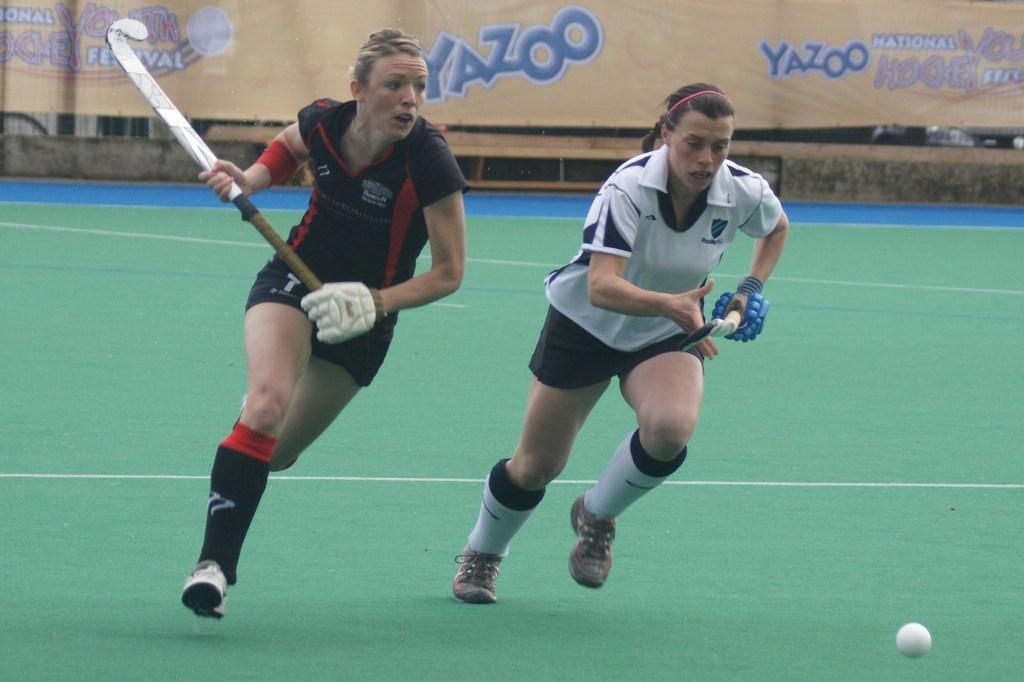Can you describe this image briefly? In this image there are persons playing hockey. In the background there is a board with some text written on it. In the front there is a ball which is white in colour. 